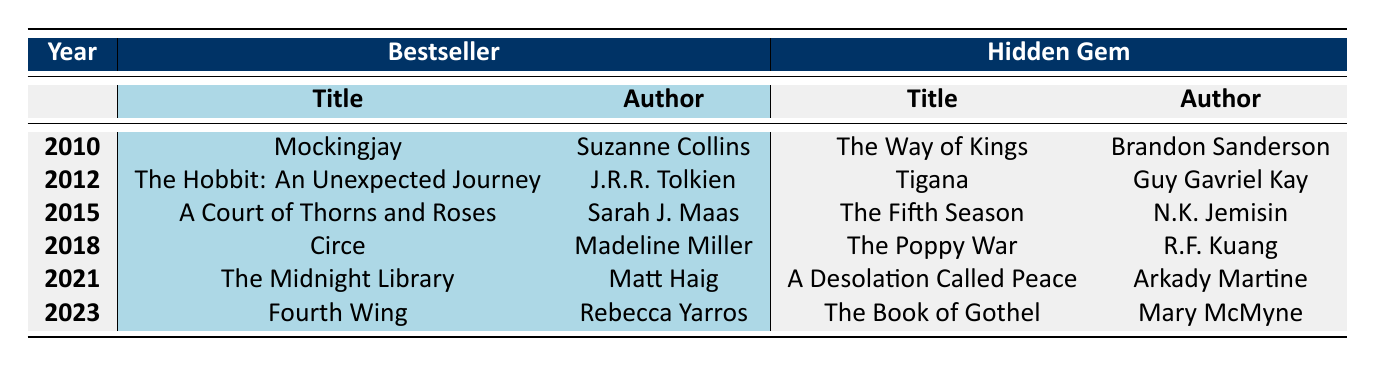What is the title of the bestseller in 2010? The table clearly states that the bestseller of 2010 is "Mockingjay."
Answer: Mockingjay Which hidden gem has the highest sales? Analyzing the hidden gems, "The Way of Kings" has 850,000 sales, which is higher than the other hidden gems listed.
Answer: The Way of Kings How many books are listed as bestsellers in the table? There is one bestseller listed for each of the six years present in the table, which totals to 6 bestsellers.
Answer: 6 What is the difference in sales between the bestseller and hidden gem for 2012? For 2012, the bestseller "The Hobbit: An Unexpected Journey" has sales of 15,000,000, while the hidden gem "Tigana" has sales of 30,000. The difference is 15,000,000 - 30,000 = 14,970,000.
Answer: 14,970,000 Which author wrote the hidden gem titled "The Poppy War"? The table indicates that "The Poppy War" is authored by R.F. Kuang.
Answer: R.F. Kuang What is the total sales of all bestsellers listed in the table? Calculating the total sales of all bestsellers: 8,200,000 (2010) + 15,000,000 (2012) + 6,000,000 (2015) + 3,000,000 (2018) + 8,000,000 (2021) + 5,000,000 (2023) = 45,200,000.
Answer: 45,200,000 Is "The Fifth Season" more popular than "A Court of Thorns and Roses"? Considering the sales, "A Court of Thorns and Roses" has 6,000,000, while "The Fifth Season" has 400,000. Since 6,000,000 is greater than 400,000, "A Court of Thorns and Roses" is more popular.
Answer: Yes Which hidden gem released in 2021 has the lowest sales? The hidden gem "A Desolation Called Peace" released in 2021 has sales of 100,000, which is lower than the sales of hidden gems from other years.
Answer: A Desolation Called Peace What year saw the release of both a bestseller and a hidden gem with titles beginning with "T"? The year 2012 has the bestseller "The Hobbit: An Unexpected Journey" and the hidden gem "Tigana," which starts with "T."
Answer: 2012 How many more sales did the bestseller in 2018 have compared to its hidden gem? For 2018, "Circe" has 3,000,000 sales and "The Poppy War" has 500,000. The difference is 3,000,000 - 500,000 = 2,500,000.
Answer: 2,500,000 Which year features the highest sales for a hidden gem? The table shows "The Way of Kings" in 2010 with 850,000 sales as the highest for hidden gems.
Answer: 2010 